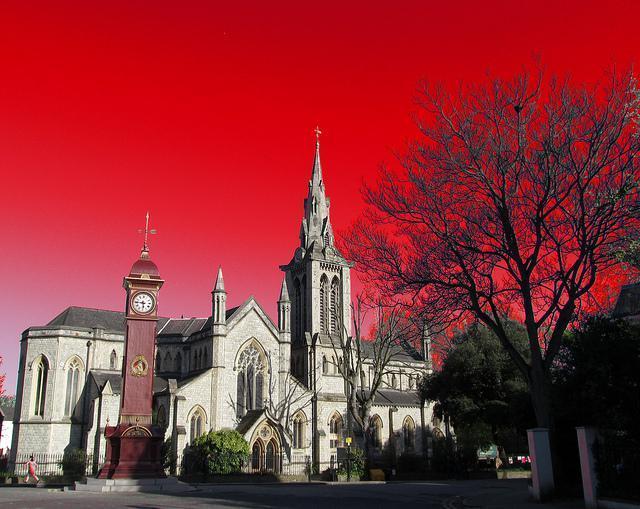How many birds are there?
Give a very brief answer. 0. 